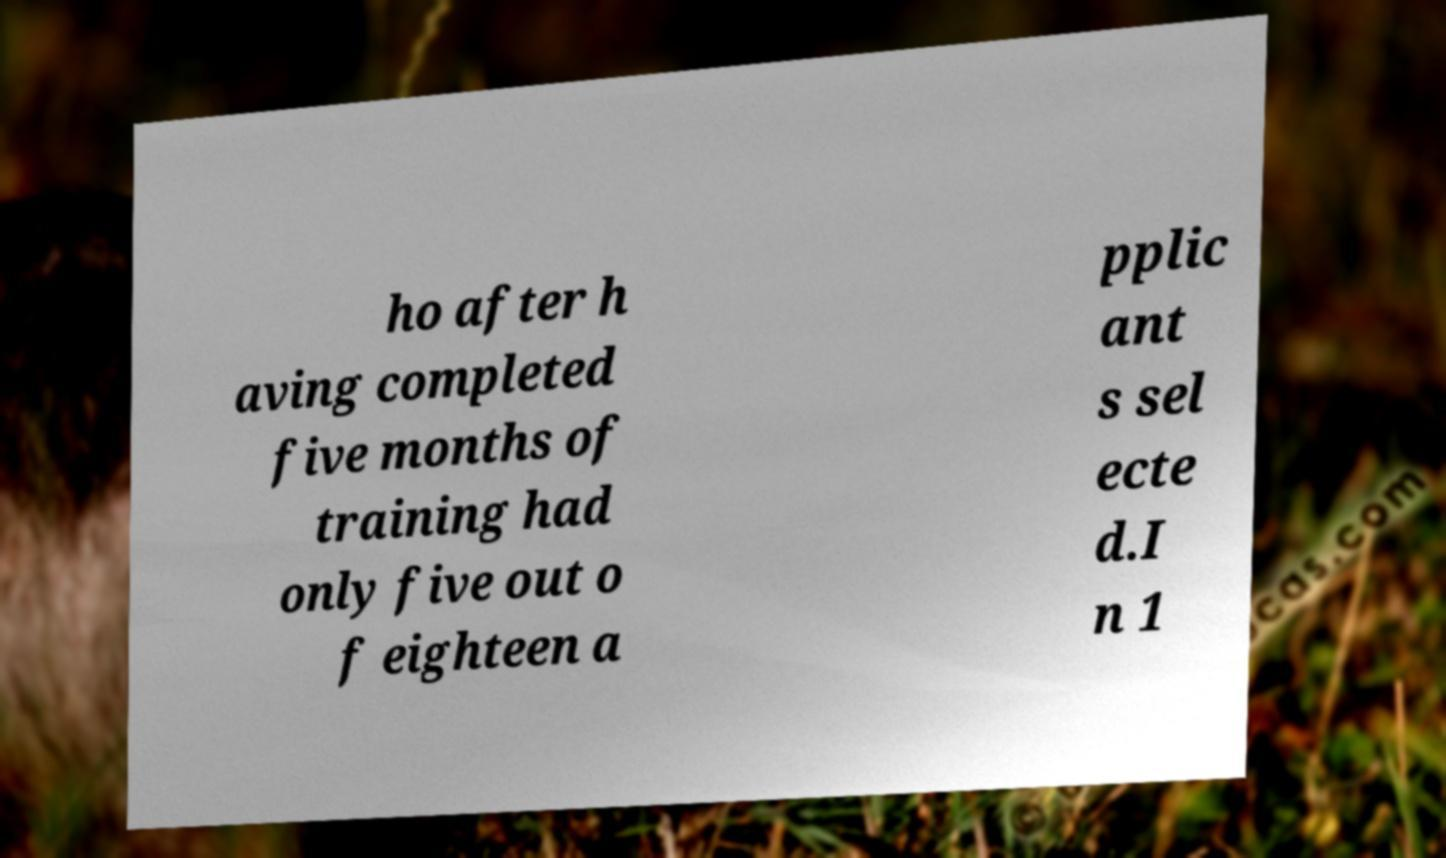Can you accurately transcribe the text from the provided image for me? ho after h aving completed five months of training had only five out o f eighteen a pplic ant s sel ecte d.I n 1 